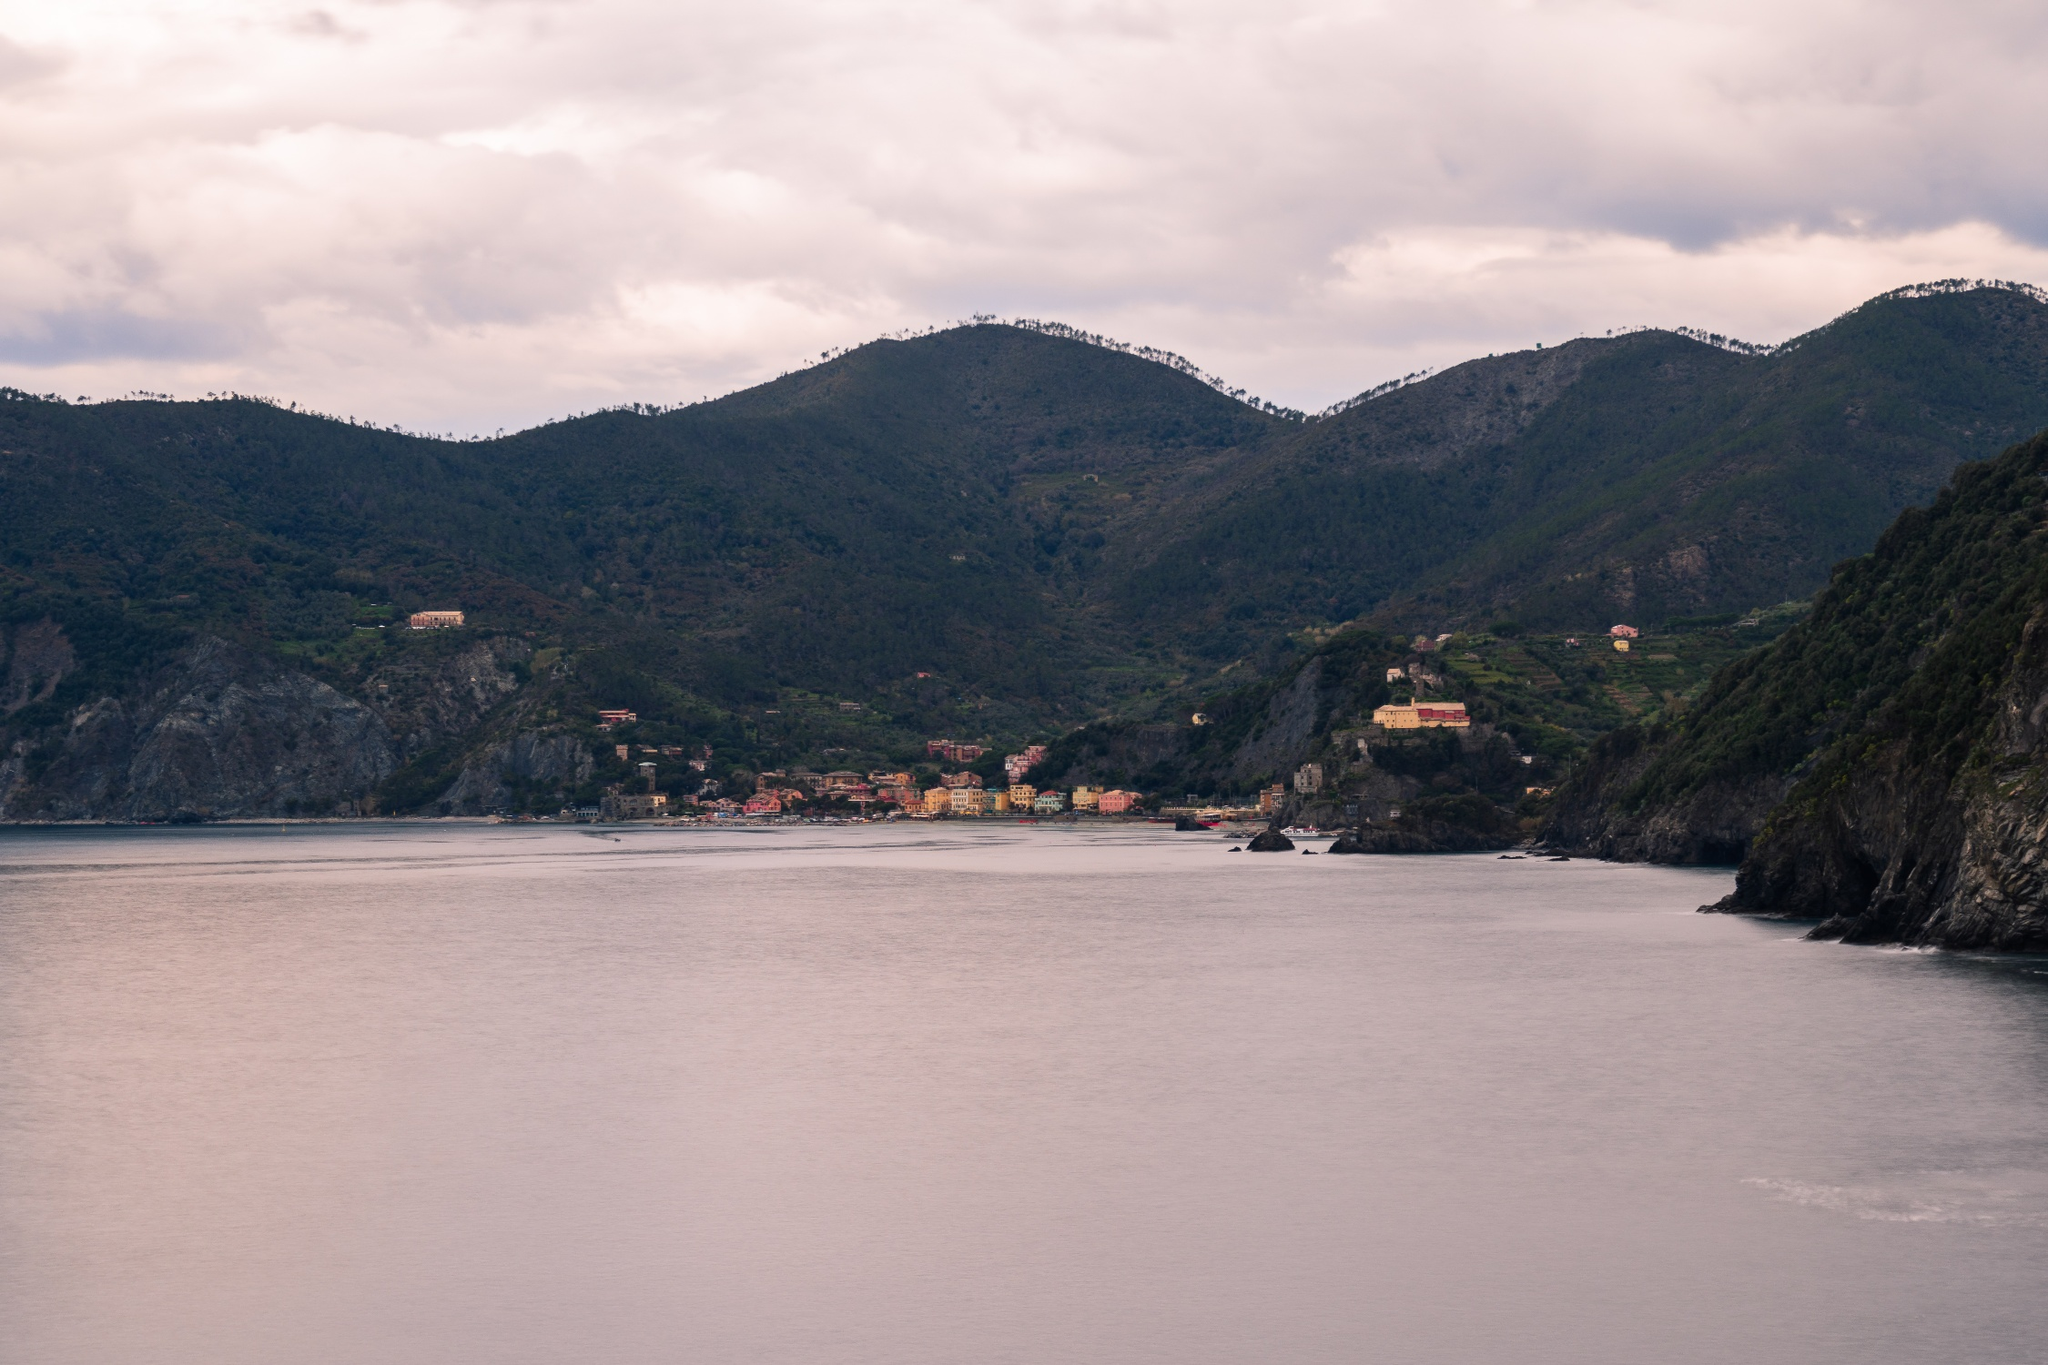Imagine you are standing on the cliff overlooking this town. Describe what you see, hear, and smell. Standing on the cliff, the panoramic view of the town and sea is breathtaking. I see the vibrant buildings clustered along the coastline, each painted in lively hues that pop against the green hills and gray cliffs. The sea stretches far into the horizon, its gentle waves creating a soft murmur that soothes the senses. The air carries a mix of scents – the salty tang of the sea, the fresh, earthy aroma of the surrounding vegetation, and a faint hint of seafood likely wafting from the town below. Gulls occasionally cry out, adding a touch of liveliness to the otherwise serene atmosphere. The scene makes me wonder about the daily life in this town. What do you think the inhabitants do during the day? Daily life in this picturesque coastal town is likely a blend of traditional and modern practices. Many residents might be involved in fishing, given the town's proximity to the sea, spending early mornings casting nets and returning with fresh catch for the local markets. Others might tend to small gardens or vineyards on the hillside terraces. The town likely has small, family-owned shops, and cafes that residents run, catering to both locals and tourists. During the warmer months, the town could see more activity with visitors exploring the winding streets, enjoying the local cuisine, or embarking on boat trips along the stunning coastline. Life here seems to move at a gentle pace, with a strong sense of community and connection to the natural surroundings. 